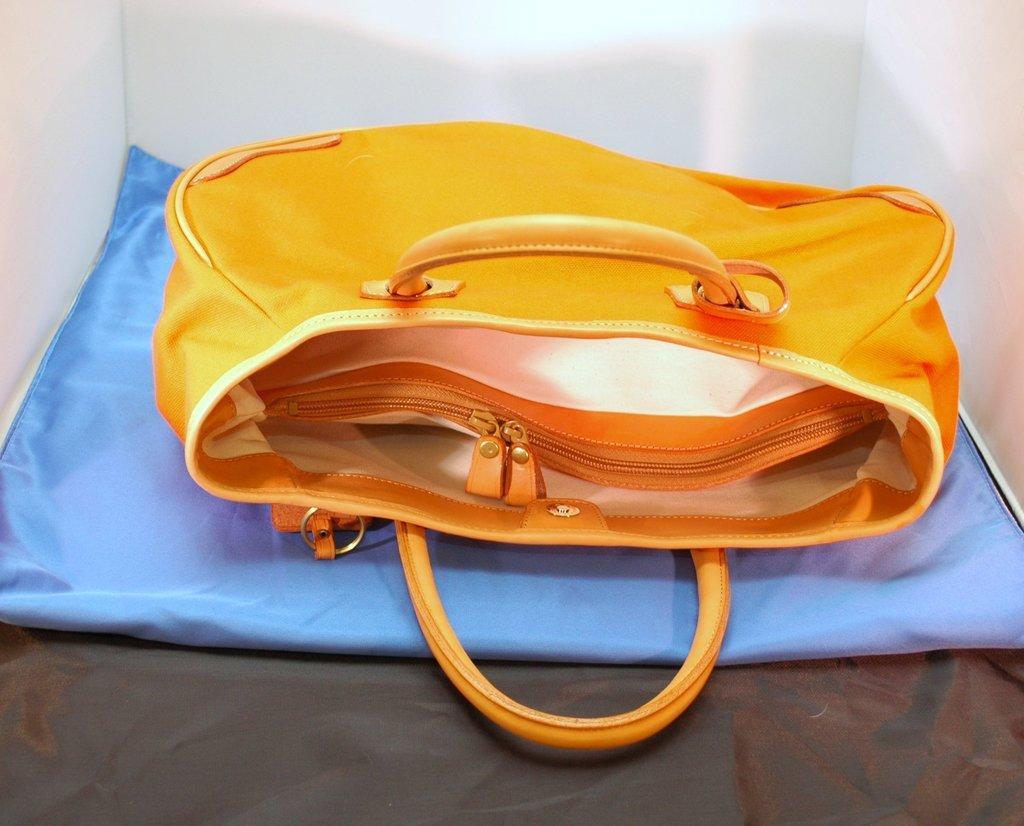Please provide a concise description of this image. In this picture we can see a orange color bag with zips and this bag is placed on a blue color cloth. 